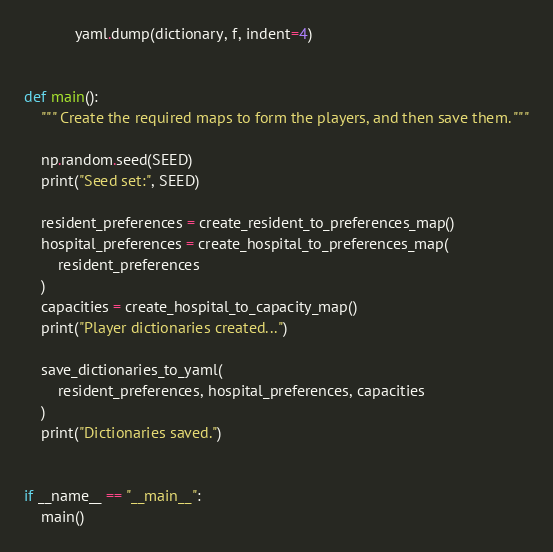<code> <loc_0><loc_0><loc_500><loc_500><_Python_>            yaml.dump(dictionary, f, indent=4)


def main():
    """ Create the required maps to form the players, and then save them. """

    np.random.seed(SEED)
    print("Seed set:", SEED)

    resident_preferences = create_resident_to_preferences_map()
    hospital_preferences = create_hospital_to_preferences_map(
        resident_preferences
    )
    capacities = create_hospital_to_capacity_map()
    print("Player dictionaries created...")

    save_dictionaries_to_yaml(
        resident_preferences, hospital_preferences, capacities
    )
    print("Dictionaries saved.")


if __name__ == "__main__":
    main()
</code> 